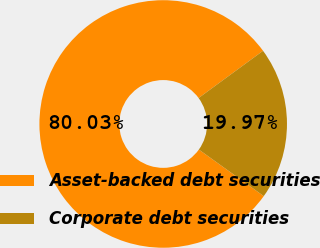<chart> <loc_0><loc_0><loc_500><loc_500><pie_chart><fcel>Asset-backed debt securities<fcel>Corporate debt securities<nl><fcel>80.03%<fcel>19.97%<nl></chart> 